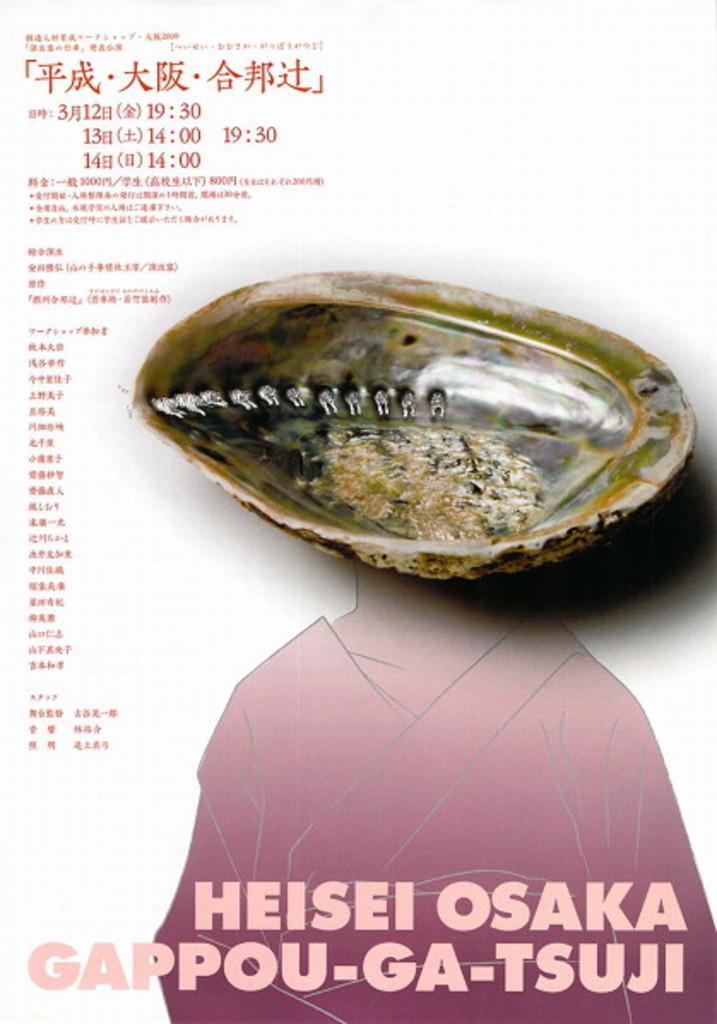How would you summarize this image in a sentence or two? This image consists of a poster. On which, we can see a shell and text. 